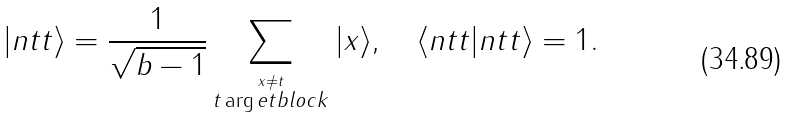Convert formula to latex. <formula><loc_0><loc_0><loc_500><loc_500>| n t t \rangle = \frac { 1 } { \sqrt { b - 1 } } \sum _ { \stackrel { x \neq t } { t \arg e t b l o c k } } | x \rangle , \quad \langle n t t | n t t \rangle = 1 .</formula> 